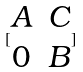<formula> <loc_0><loc_0><loc_500><loc_500>[ \begin{matrix} A & C \\ 0 & B \end{matrix} ]</formula> 